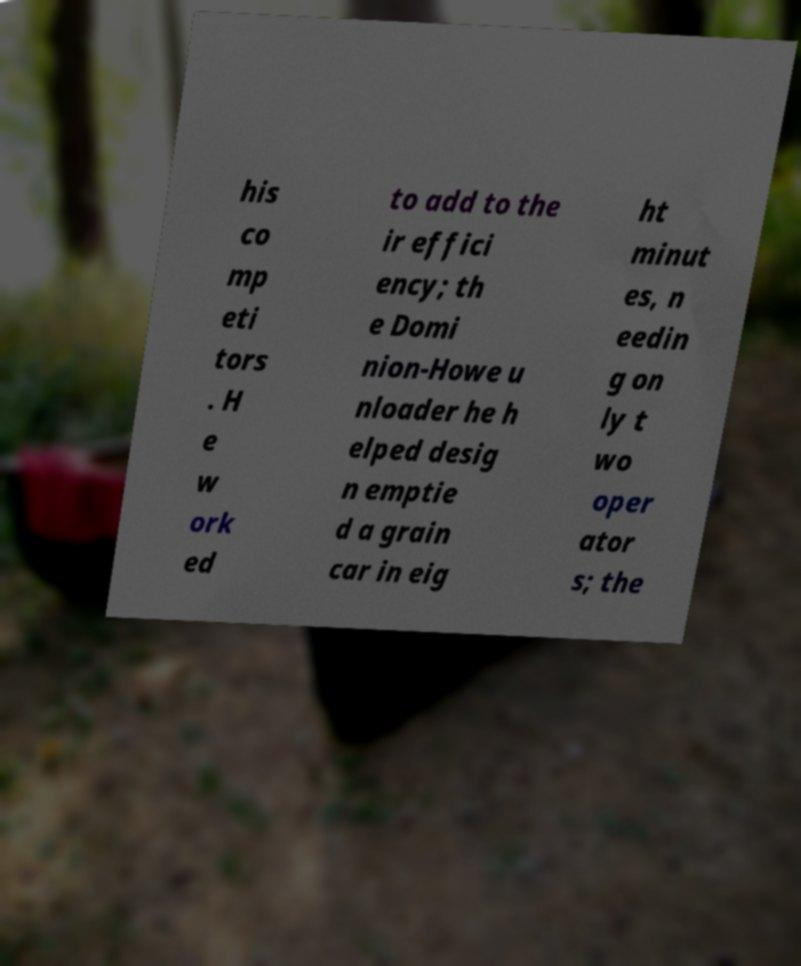I need the written content from this picture converted into text. Can you do that? his co mp eti tors . H e w ork ed to add to the ir effici ency; th e Domi nion-Howe u nloader he h elped desig n emptie d a grain car in eig ht minut es, n eedin g on ly t wo oper ator s; the 